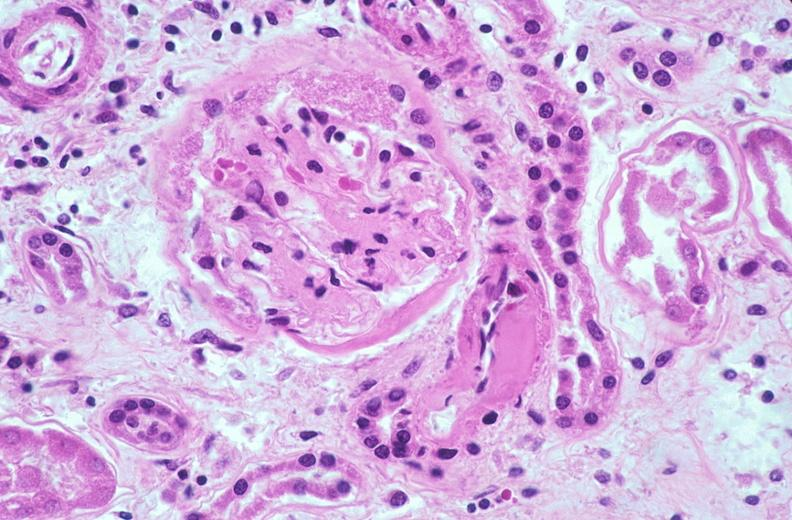does this image show kidney glomerulus, thickened and hyalinized basement membranes fibrin caps due to diabetes mellitus?
Answer the question using a single word or phrase. Yes 